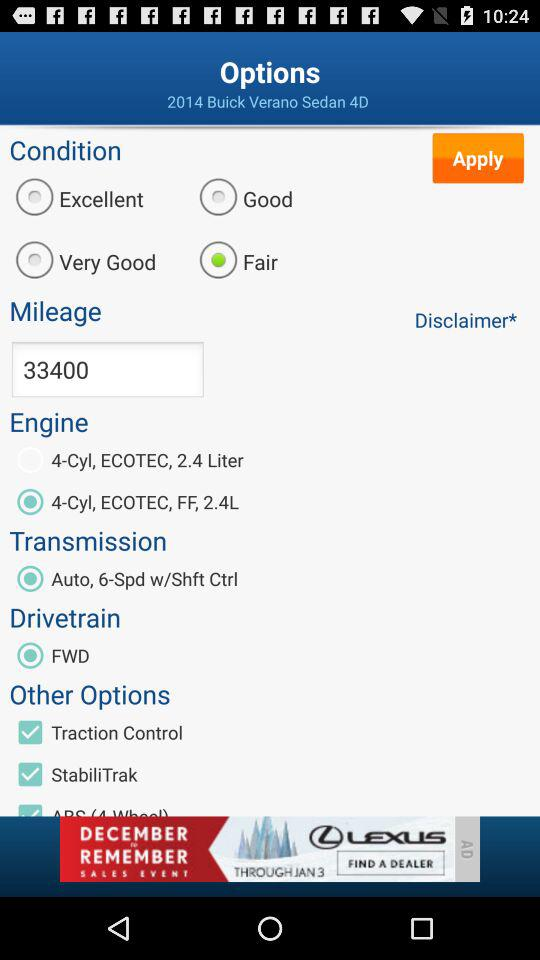Which option is selected for "Engine"? The selected option is "4-Cyl, ECOTEC, FF, 2.4L". 